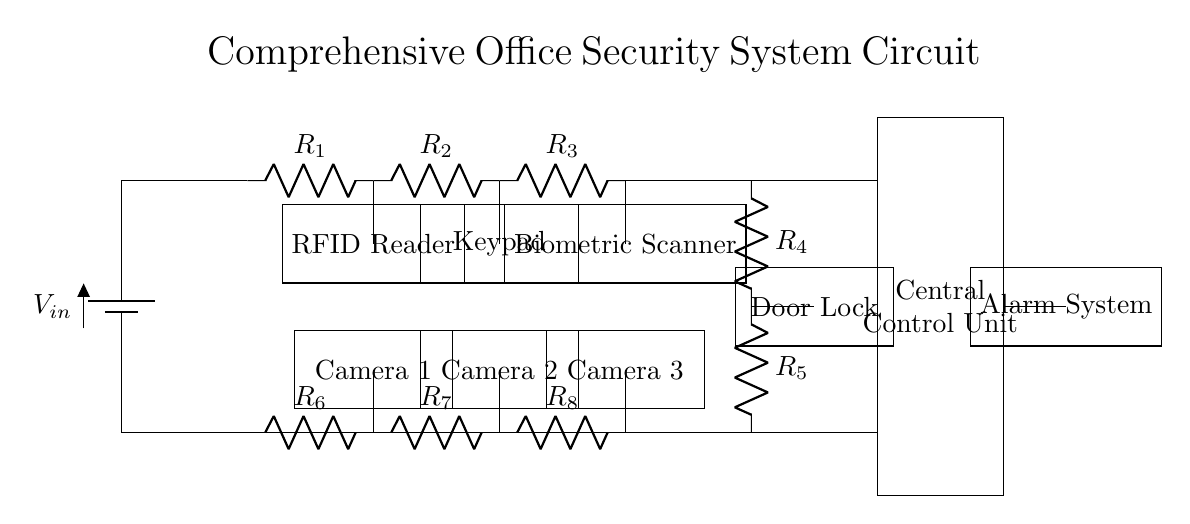What power source is used in the circuit? The circuit is powered by a battery, as indicated by the symbol for a battery labeled V_in at the top left of the diagram.
Answer: Battery What components are part of the access control system? The access control system includes an RFID reader, a keypad, a biometric scanner, and a door lock, all represented as blocks connected to various resistors in the top section of the circuit.
Answer: RFID reader, keypad, biometric scanner, door lock How many surveillance cameras are in the circuit? There are three surveillance cameras indicated by the labels Camera 1, Camera 2, and Camera 3 in the lower section of the circuit diagram.
Answer: Three Which component typically initiates the alarm in this security system? The alarm system is usually activated through the central control unit, which receives signals from the access control components or motion detectors, shown connected to the alarm at the right side of the diagram.
Answer: Central control unit What is the purpose of the RFID reader in this circuit? The RFID reader functions as a means of access control, allowing authorized users to enter the premises by scanning their RFID tags, as depicted in its position connected to the main power flow of the access control part.
Answer: Access control Which components are connected in series between the power source and the central control unit? R1, R2, R3, R4, and R5 resistors are in series with the components of the access control system, connected directly from the battery to the central control unit on the upper side of the circuit.
Answer: R1, R2, R3, R4, R5 